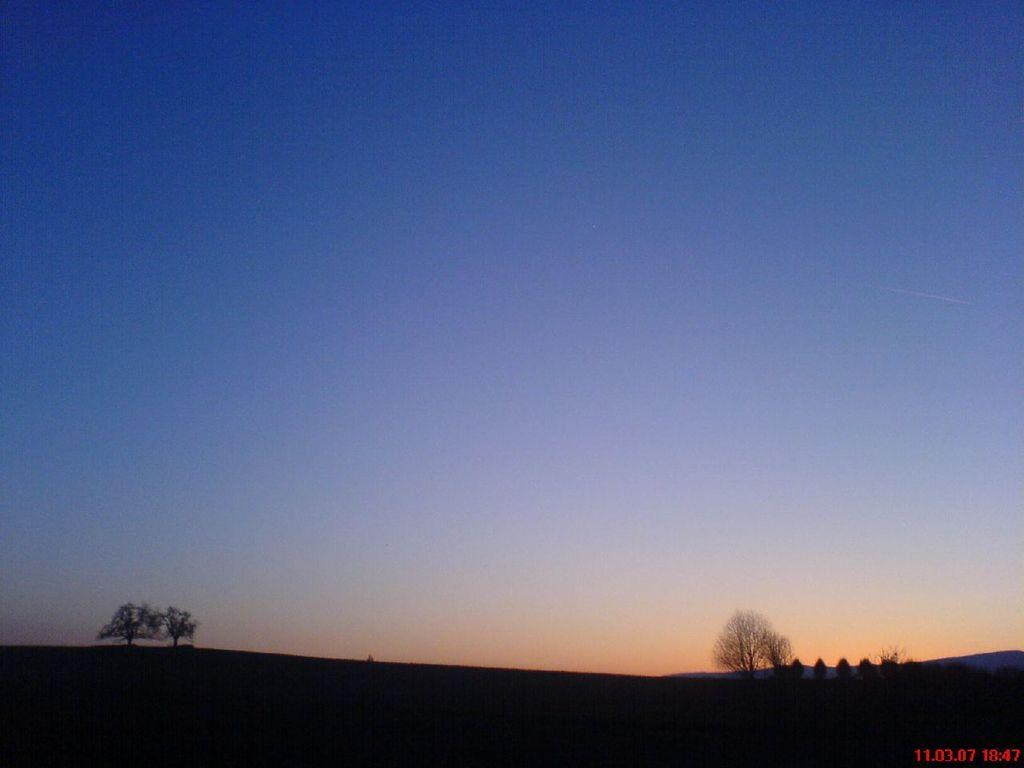What type of vegetation can be seen in the image? There are trees in the image. What is visible in the background of the image? There is a sky visible in the background of the image. Where is the chair located in the image? There is no chair present in the image. Is there any smoke visible in the image? There is no smoke visible in the image. What type of lighting fixture can be seen in the image? There is no lamp or any other lighting fixture present in the image. 